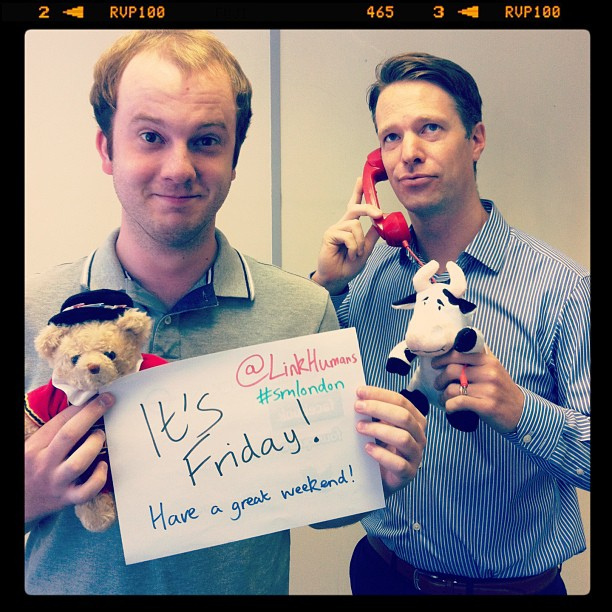Identify the text contained in this image. 2 RVP 100 465 3 RUP100 @LinkHumans It's Friday Have a great Weekend Fsmlondon 